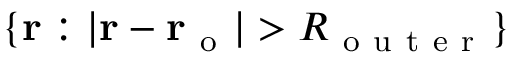Convert formula to latex. <formula><loc_0><loc_0><loc_500><loc_500>\{ r \colon | r - r _ { o } | > R _ { o u t e r } \}</formula> 